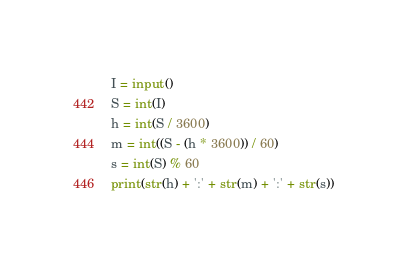Convert code to text. <code><loc_0><loc_0><loc_500><loc_500><_Python_>I = input()
S = int(I)
h = int(S / 3600)
m = int((S - (h * 3600)) / 60)
s = int(S) % 60
print(str(h) + ':' + str(m) + ':' + str(s))</code> 